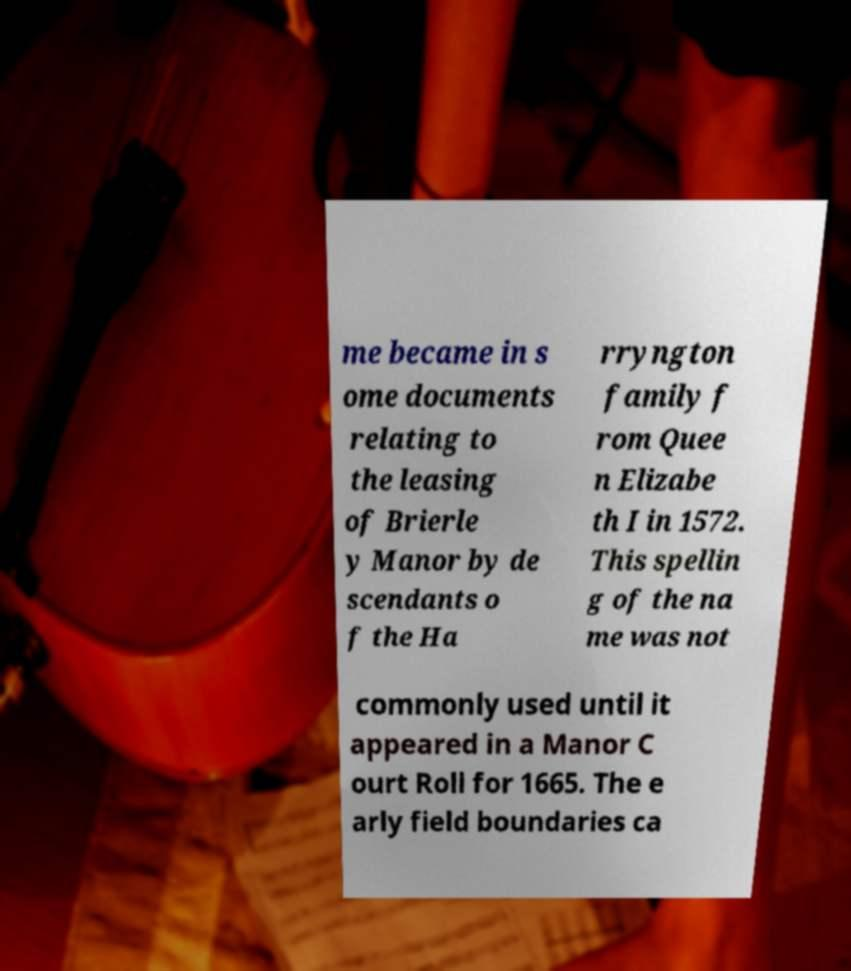Please identify and transcribe the text found in this image. me became in s ome documents relating to the leasing of Brierle y Manor by de scendants o f the Ha rryngton family f rom Quee n Elizabe th I in 1572. This spellin g of the na me was not commonly used until it appeared in a Manor C ourt Roll for 1665. The e arly field boundaries ca 